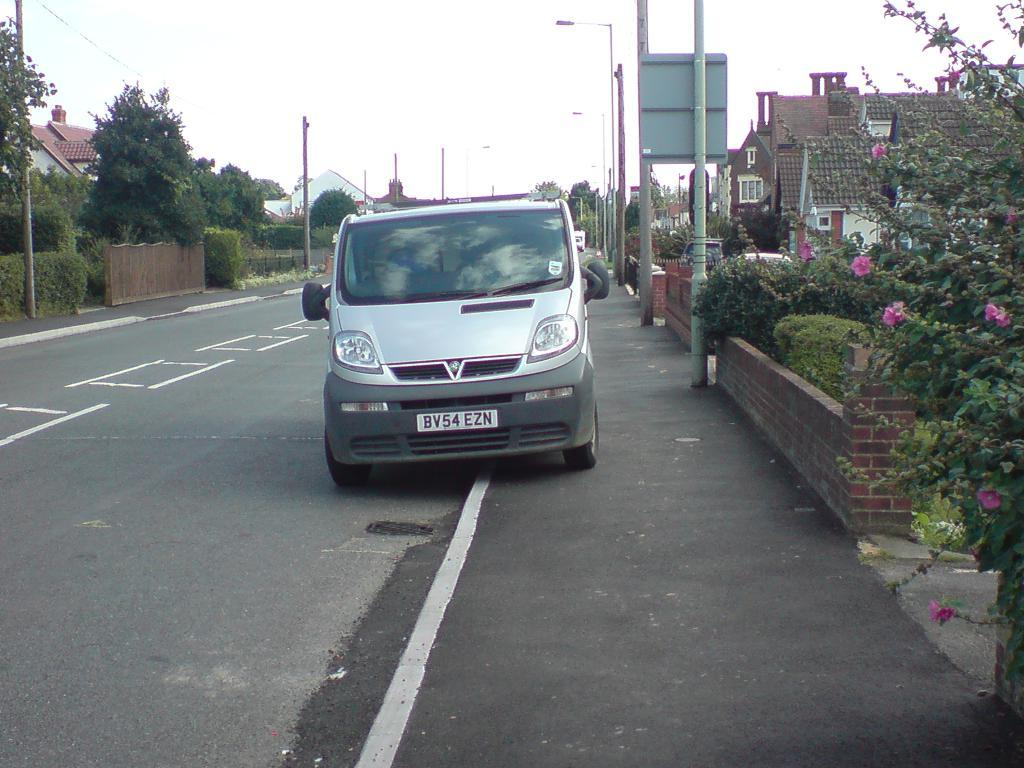What is parked beside the road in the image? There is a vehicle parked beside the road in the image. What can be seen around the road in the image? Houses, trees, plants, street lights, and other poles are visible around the road in the image. How many types of structures are present around the road in the image? There are at least three types of structures present around the road: houses, street lights, and other poles. What type of drug is being attempted to be smuggled in the image? There is no indication of any drug or smuggling activity in the image. 